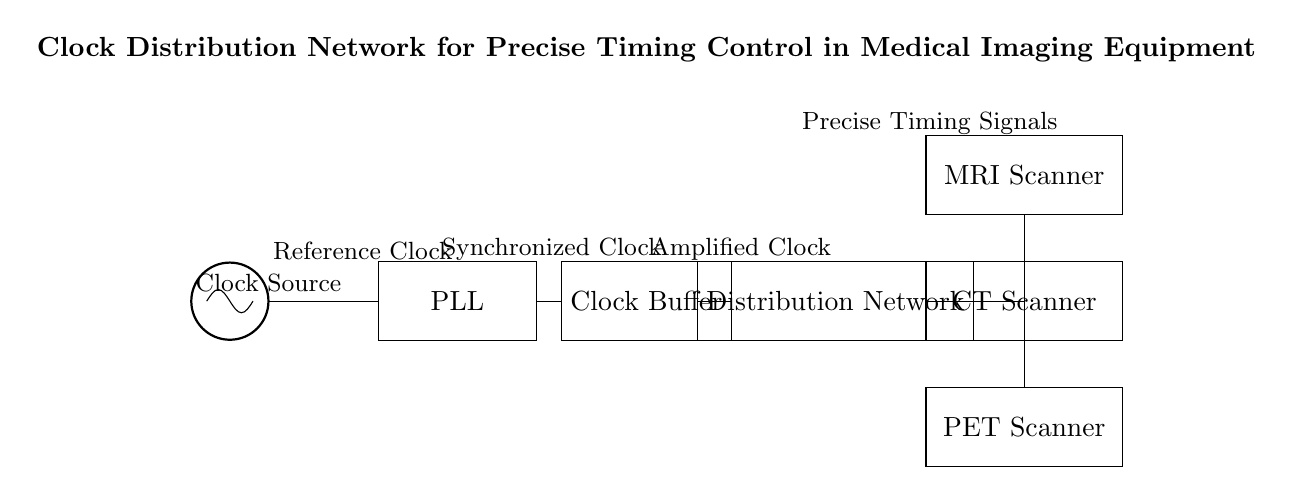What is the purpose of the PLL in the circuit? The PLL, or Phase-Locked Loop, is used to synchronize the clock signal generated from the oscillator with a desired reference frequency, ensuring accurate timing for further processing in the system.
Answer: Synchronization What component follows the clock source in the circuit? The clock source is connected to the PLL, which serves as the next component in the signal flow, processing the initial clock signal.
Answer: PLL How many medical imaging devices receive the clock signal from the distribution network? There are three medical imaging devices illustrated in the circuit that receive the clock signals from the distribution network: the MRI scanner, CT scanner, and PET scanner.
Answer: Three What type of signal does the clock buffer amplify? The clock buffer amplifies the synchronized clock signal received from the PLL, ensuring strong and stable signals are sent throughout the distribution network.
Answer: Synchronized clock Explain the flow of the clock signal from the oscillator to the imaging equipment. The clock signal begins at the oscillator, which generates the reference clock. This signal is sent to the PLL, where it gets synchronized with a desired frequency. The PLL output is then amplified by the clock buffer, and finally, the amplified clock is distributed through the distribution network to the MRI, CT, and PET scanners, ensuring precise timing control for medical imaging operations.
Answer: Oscillator → PLL → Clock Buffer → Distribution Network → Medical Equipment What role does the distribution network play in this circuit? The distribution network acts as a mediator that takes the amplified clock signal from the clock buffer and routes it to the various medical imaging devices, ensuring that each device receives the necessary timing signals for operation.
Answer: Mediator What is the starting point of the clock signal in this circuit? The starting point of the clock signal is the oscillator, which generates the initial reference clock for the entire clock distribution system.
Answer: Oscillator 